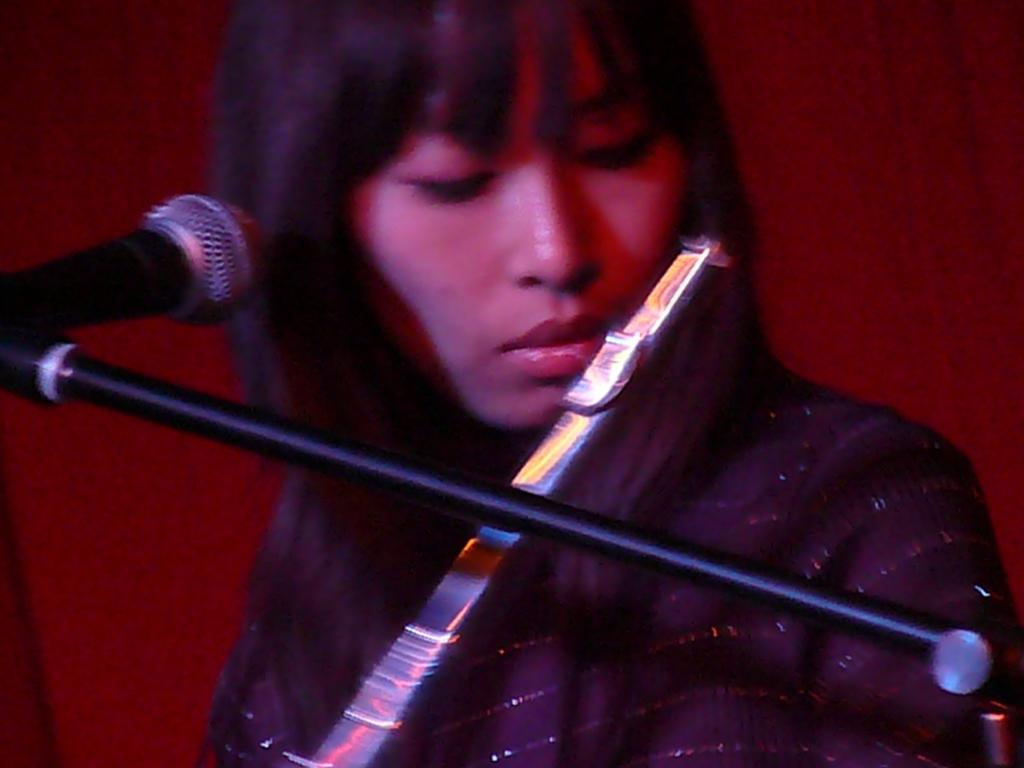Who is the main subject in the image? There is a woman in the image. What is the woman doing in the image? The woman is playing a musical instrument. What object is present in the image that is typically used for amplifying sound? There is a microphone in the image. Can you describe the background of the image? The background of the image is plain. How many pigs are visible in the image? There are no pigs present in the image. What type of home is shown in the background of the image? There is no home visible in the image; the background is plain. 